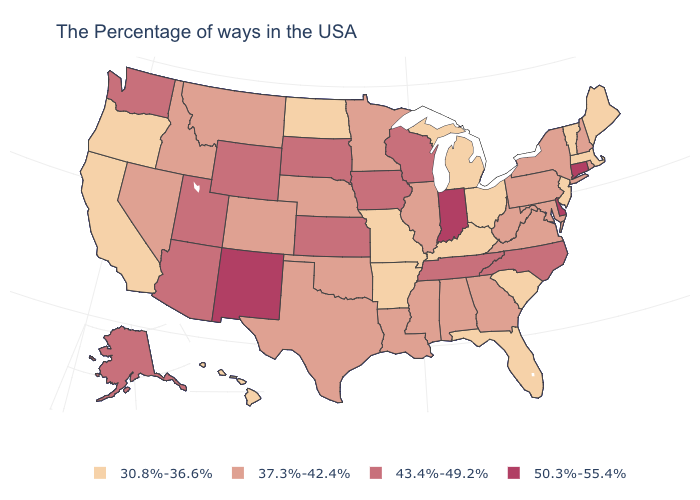What is the value of Illinois?
Keep it brief. 37.3%-42.4%. What is the value of New Hampshire?
Quick response, please. 37.3%-42.4%. Name the states that have a value in the range 37.3%-42.4%?
Concise answer only. Rhode Island, New Hampshire, New York, Maryland, Pennsylvania, Virginia, West Virginia, Georgia, Alabama, Illinois, Mississippi, Louisiana, Minnesota, Nebraska, Oklahoma, Texas, Colorado, Montana, Idaho, Nevada. Among the states that border Texas , which have the lowest value?
Quick response, please. Arkansas. Name the states that have a value in the range 37.3%-42.4%?
Quick response, please. Rhode Island, New Hampshire, New York, Maryland, Pennsylvania, Virginia, West Virginia, Georgia, Alabama, Illinois, Mississippi, Louisiana, Minnesota, Nebraska, Oklahoma, Texas, Colorado, Montana, Idaho, Nevada. Among the states that border Utah , which have the lowest value?
Give a very brief answer. Colorado, Idaho, Nevada. Which states have the lowest value in the USA?
Give a very brief answer. Maine, Massachusetts, Vermont, New Jersey, South Carolina, Ohio, Florida, Michigan, Kentucky, Missouri, Arkansas, North Dakota, California, Oregon, Hawaii. Among the states that border Wyoming , which have the lowest value?
Write a very short answer. Nebraska, Colorado, Montana, Idaho. Among the states that border Mississippi , which have the lowest value?
Short answer required. Arkansas. What is the lowest value in the West?
Concise answer only. 30.8%-36.6%. Does Alabama have the lowest value in the South?
Concise answer only. No. Among the states that border Wyoming , does Utah have the highest value?
Give a very brief answer. Yes. Name the states that have a value in the range 50.3%-55.4%?
Answer briefly. Connecticut, Delaware, Indiana, New Mexico. Name the states that have a value in the range 50.3%-55.4%?
Short answer required. Connecticut, Delaware, Indiana, New Mexico. 